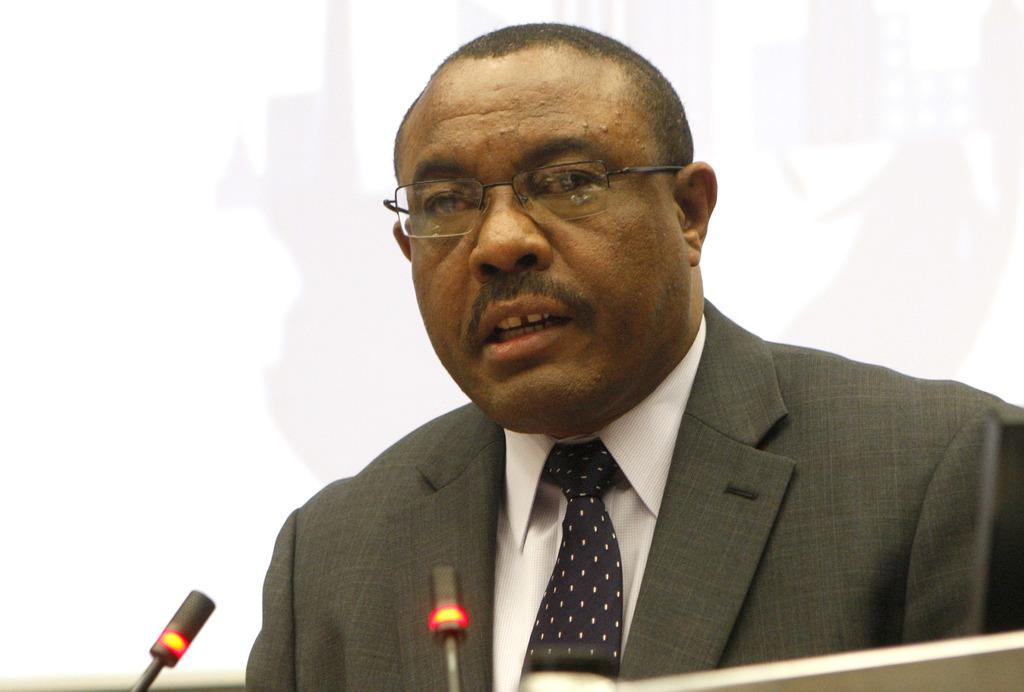Who is the person in the image? There is a man in the image. What is the man wearing? The man is wearing a suit, shirt, and tie. What is in front of the man? There is a podium in front of the man. What is on the podium? There are microphones on the podium. What can be seen in the background of the image? There is a screen and a wall in the background of the image. What type of hot drink is the man holding in the image? There is no hot drink visible in the image; the man is not holding anything. Can you see any squirrels in the image? There are no squirrels present in the image. 